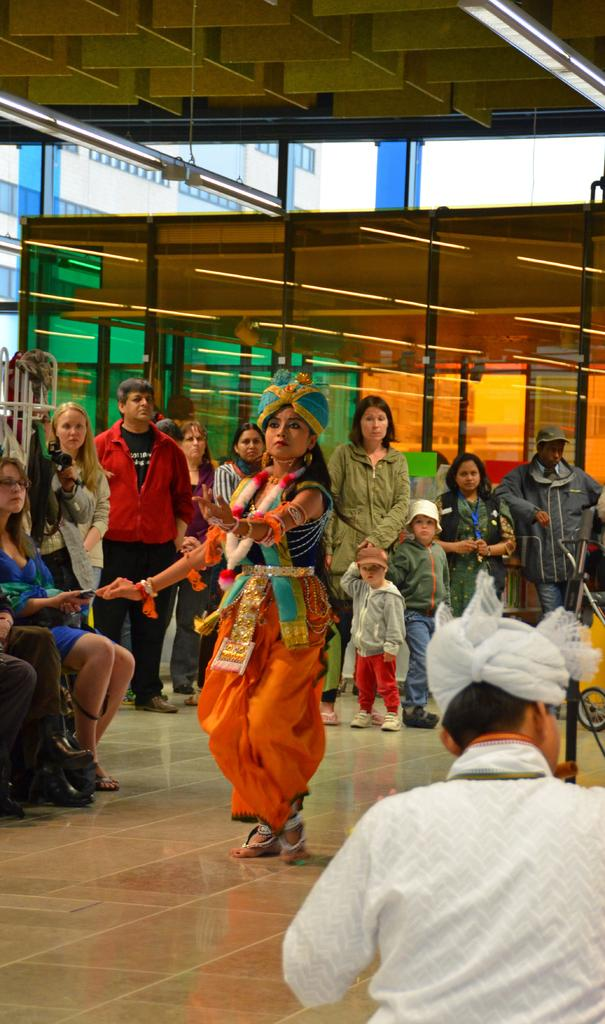What is the woman in the image doing? The woman is standing and dancing in the image. Where is the woman located in the image? The woman is on the road in the image. What can be seen in the background of the image? There are other people and buildings visible in the image. What is the condition of the sky in the image? The sky is clear in the image. What type of eggs can be seen in the woman's hands in the image? There are no eggs present in the image; the woman is dancing and does not have any eggs in her hands. 